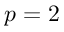Convert formula to latex. <formula><loc_0><loc_0><loc_500><loc_500>p = 2</formula> 